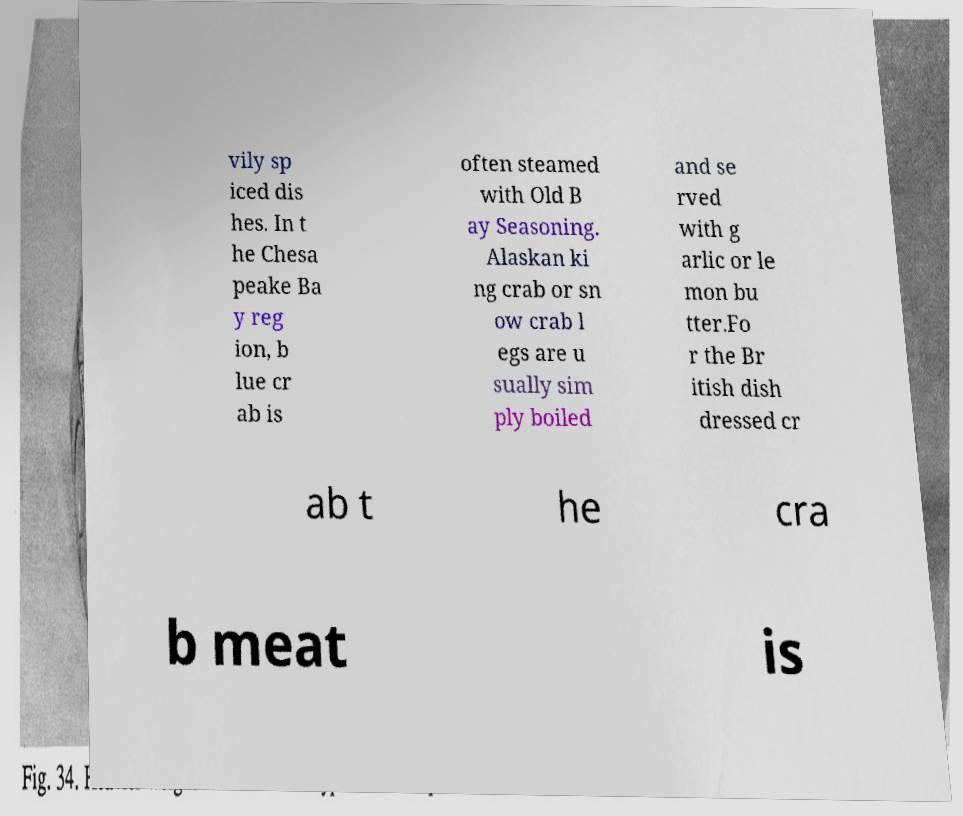Could you extract and type out the text from this image? vily sp iced dis hes. In t he Chesa peake Ba y reg ion, b lue cr ab is often steamed with Old B ay Seasoning. Alaskan ki ng crab or sn ow crab l egs are u sually sim ply boiled and se rved with g arlic or le mon bu tter.Fo r the Br itish dish dressed cr ab t he cra b meat is 